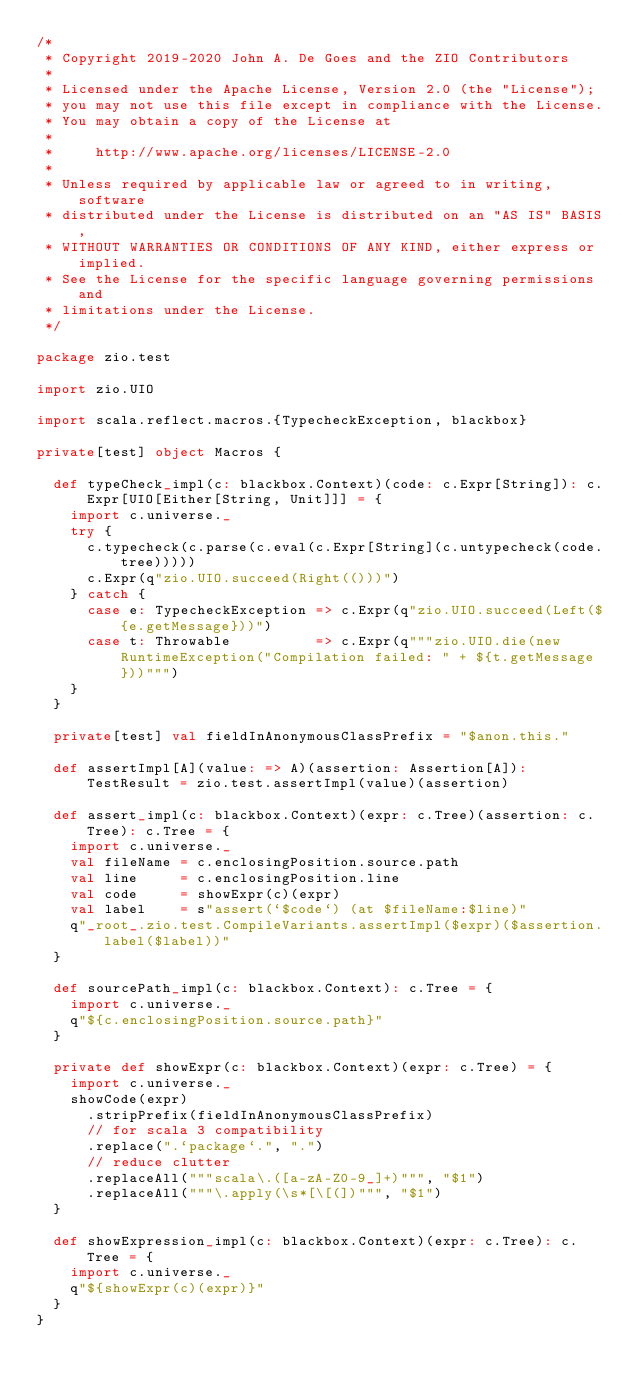Convert code to text. <code><loc_0><loc_0><loc_500><loc_500><_Scala_>/*
 * Copyright 2019-2020 John A. De Goes and the ZIO Contributors
 *
 * Licensed under the Apache License, Version 2.0 (the "License");
 * you may not use this file except in compliance with the License.
 * You may obtain a copy of the License at
 *
 *     http://www.apache.org/licenses/LICENSE-2.0
 *
 * Unless required by applicable law or agreed to in writing, software
 * distributed under the License is distributed on an "AS IS" BASIS,
 * WITHOUT WARRANTIES OR CONDITIONS OF ANY KIND, either express or implied.
 * See the License for the specific language governing permissions and
 * limitations under the License.
 */

package zio.test

import zio.UIO

import scala.reflect.macros.{TypecheckException, blackbox}

private[test] object Macros {

  def typeCheck_impl(c: blackbox.Context)(code: c.Expr[String]): c.Expr[UIO[Either[String, Unit]]] = {
    import c.universe._
    try {
      c.typecheck(c.parse(c.eval(c.Expr[String](c.untypecheck(code.tree)))))
      c.Expr(q"zio.UIO.succeed(Right(()))")
    } catch {
      case e: TypecheckException => c.Expr(q"zio.UIO.succeed(Left(${e.getMessage}))")
      case t: Throwable          => c.Expr(q"""zio.UIO.die(new RuntimeException("Compilation failed: " + ${t.getMessage}))""")
    }
  }

  private[test] val fieldInAnonymousClassPrefix = "$anon.this."

  def assertImpl[A](value: => A)(assertion: Assertion[A]): TestResult = zio.test.assertImpl(value)(assertion)

  def assert_impl(c: blackbox.Context)(expr: c.Tree)(assertion: c.Tree): c.Tree = {
    import c.universe._
    val fileName = c.enclosingPosition.source.path
    val line     = c.enclosingPosition.line
    val code     = showExpr(c)(expr)
    val label    = s"assert(`$code`) (at $fileName:$line)"
    q"_root_.zio.test.CompileVariants.assertImpl($expr)($assertion.label($label))"
  }

  def sourcePath_impl(c: blackbox.Context): c.Tree = {
    import c.universe._
    q"${c.enclosingPosition.source.path}"
  }

  private def showExpr(c: blackbox.Context)(expr: c.Tree) = {
    import c.universe._
    showCode(expr)
      .stripPrefix(fieldInAnonymousClassPrefix)
      // for scala 3 compatibility
      .replace(".`package`.", ".")
      // reduce clutter
      .replaceAll("""scala\.([a-zA-Z0-9_]+)""", "$1")
      .replaceAll("""\.apply(\s*[\[(])""", "$1")
  }

  def showExpression_impl(c: blackbox.Context)(expr: c.Tree): c.Tree = {
    import c.universe._
    q"${showExpr(c)(expr)}"
  }
}
</code> 